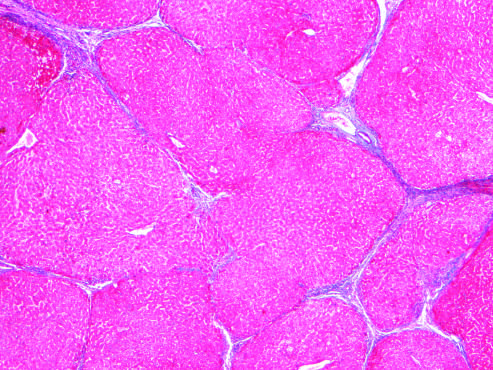what are gone after 1 year of abstinence?
Answer the question using a single word or phrase. Most scars 